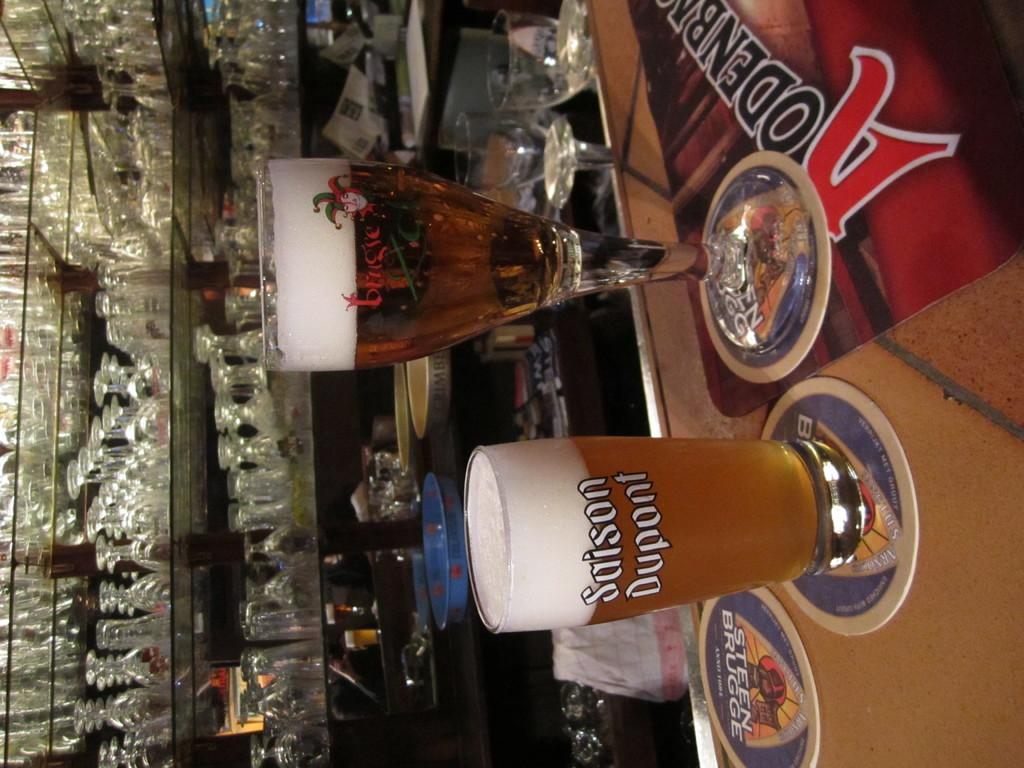<image>
Offer a succinct explanation of the picture presented. The Saison Dupont brand of beer is served up on a bar counter. 